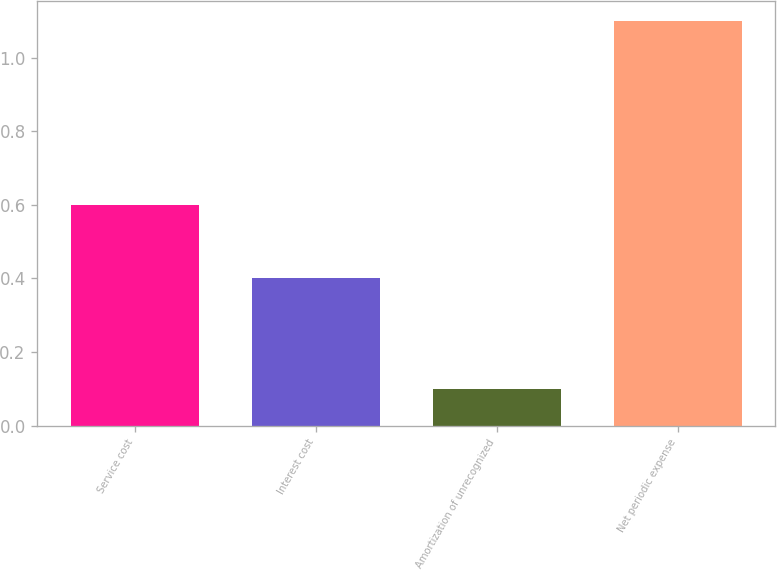<chart> <loc_0><loc_0><loc_500><loc_500><bar_chart><fcel>Service cost<fcel>Interest cost<fcel>Amortization of unrecognized<fcel>Net periodic expense<nl><fcel>0.6<fcel>0.4<fcel>0.1<fcel>1.1<nl></chart> 